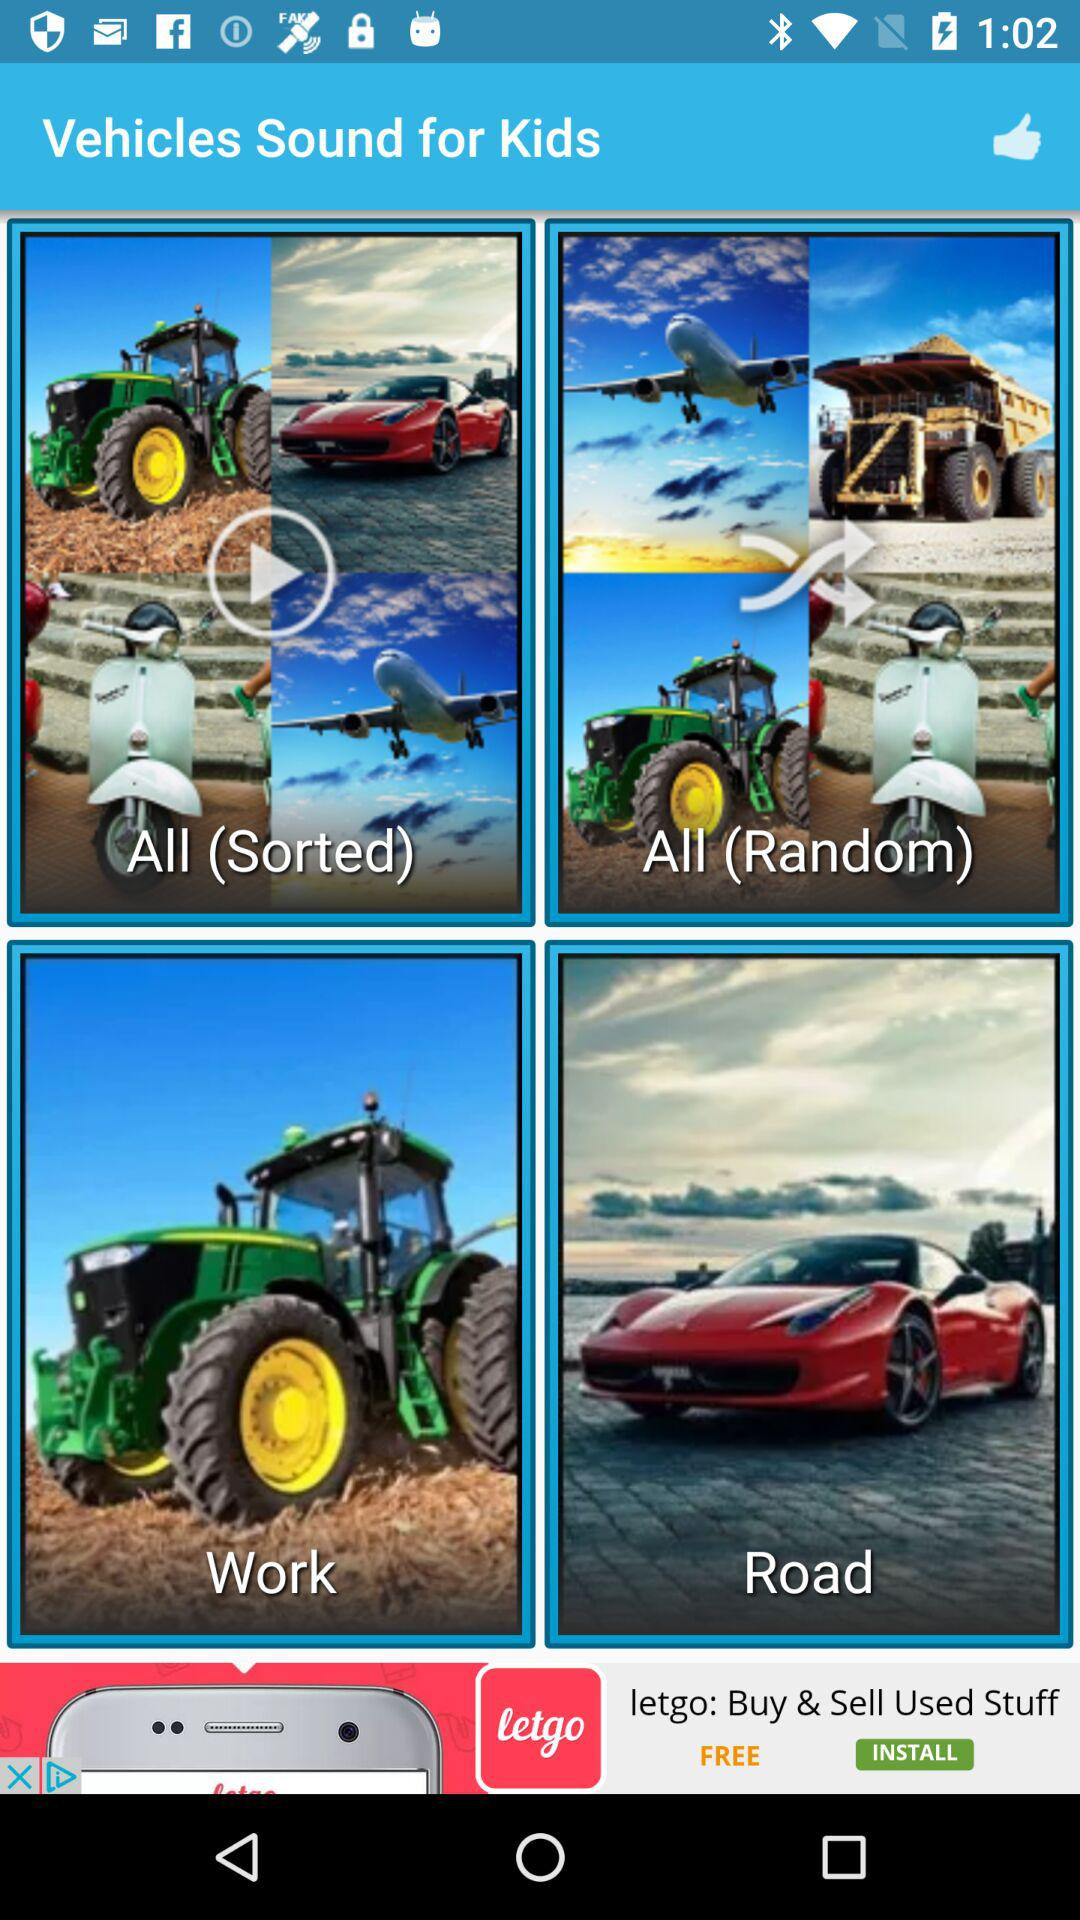What is the application name? The application name is "Vehicles Sound for Kids". 